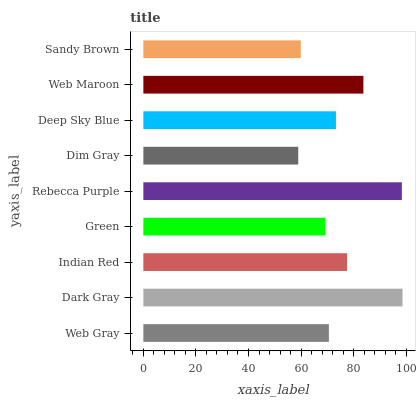Is Dim Gray the minimum?
Answer yes or no. Yes. Is Dark Gray the maximum?
Answer yes or no. Yes. Is Indian Red the minimum?
Answer yes or no. No. Is Indian Red the maximum?
Answer yes or no. No. Is Dark Gray greater than Indian Red?
Answer yes or no. Yes. Is Indian Red less than Dark Gray?
Answer yes or no. Yes. Is Indian Red greater than Dark Gray?
Answer yes or no. No. Is Dark Gray less than Indian Red?
Answer yes or no. No. Is Deep Sky Blue the high median?
Answer yes or no. Yes. Is Deep Sky Blue the low median?
Answer yes or no. Yes. Is Sandy Brown the high median?
Answer yes or no. No. Is Dim Gray the low median?
Answer yes or no. No. 